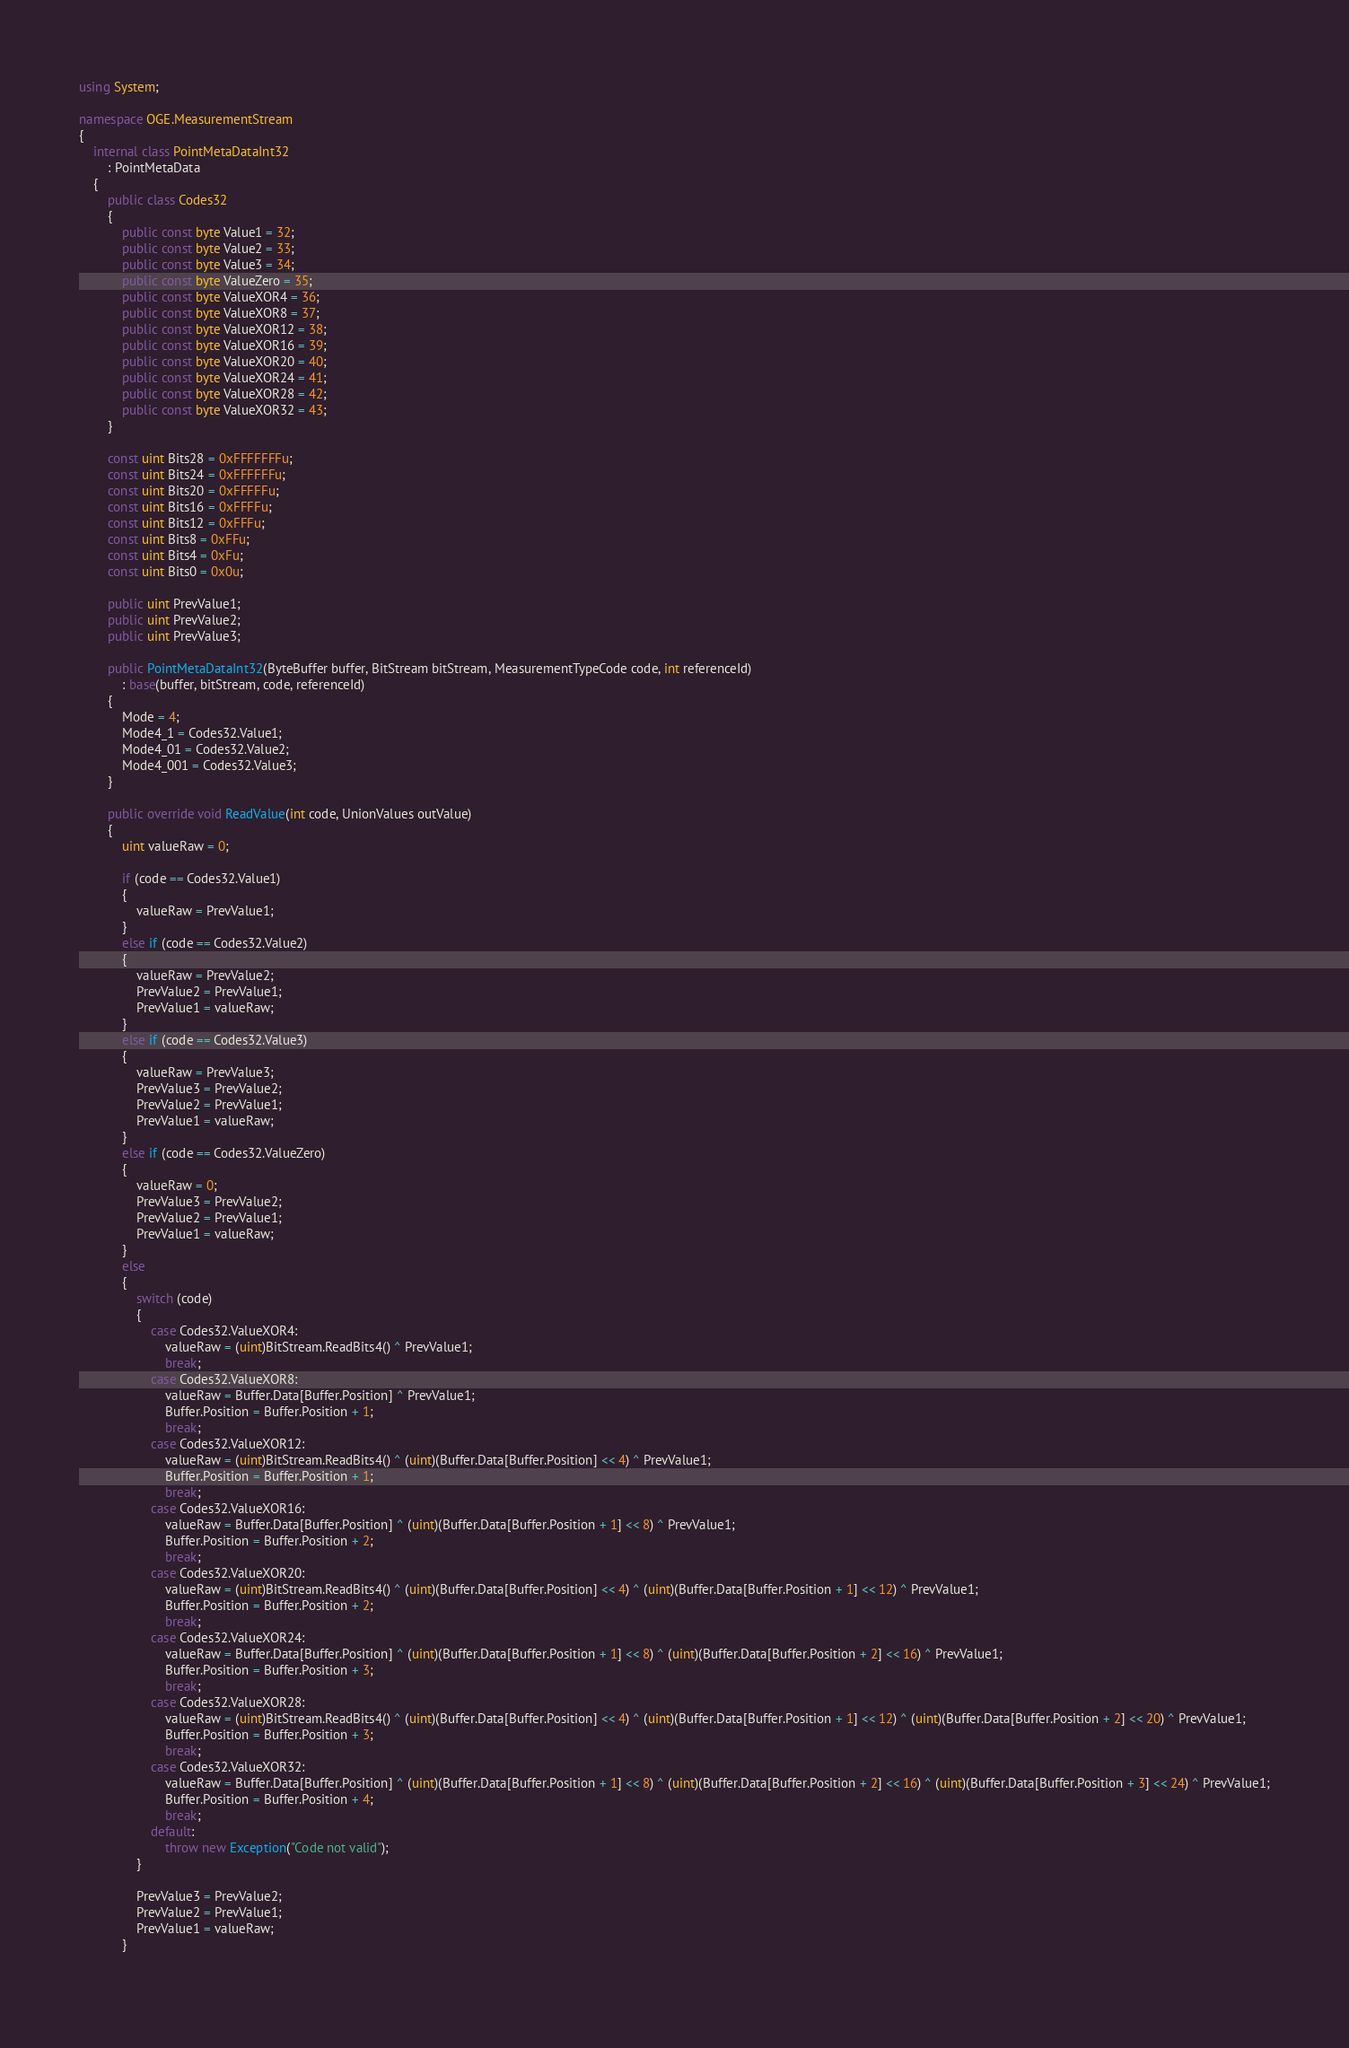<code> <loc_0><loc_0><loc_500><loc_500><_C#_>using System;

namespace OGE.MeasurementStream
{
    internal class PointMetaDataInt32
        : PointMetaData
    {
        public class Codes32
        {
            public const byte Value1 = 32;
            public const byte Value2 = 33;
            public const byte Value3 = 34;
            public const byte ValueZero = 35;
            public const byte ValueXOR4 = 36;
            public const byte ValueXOR8 = 37;
            public const byte ValueXOR12 = 38;
            public const byte ValueXOR16 = 39;
            public const byte ValueXOR20 = 40;
            public const byte ValueXOR24 = 41;
            public const byte ValueXOR28 = 42;
            public const byte ValueXOR32 = 43;
        }

        const uint Bits28 = 0xFFFFFFFu;
        const uint Bits24 = 0xFFFFFFu;
        const uint Bits20 = 0xFFFFFu;
        const uint Bits16 = 0xFFFFu;
        const uint Bits12 = 0xFFFu;
        const uint Bits8 = 0xFFu;
        const uint Bits4 = 0xFu;
        const uint Bits0 = 0x0u;

        public uint PrevValue1;
        public uint PrevValue2;
        public uint PrevValue3;

        public PointMetaDataInt32(ByteBuffer buffer, BitStream bitStream, MeasurementTypeCode code, int referenceId)
            : base(buffer, bitStream, code, referenceId)
        {
            Mode = 4;
            Mode4_1 = Codes32.Value1;
            Mode4_01 = Codes32.Value2;
            Mode4_001 = Codes32.Value3;
        }

        public override void ReadValue(int code, UnionValues outValue)
        {
            uint valueRaw = 0;

            if (code == Codes32.Value1)
            {
                valueRaw = PrevValue1;
            }
            else if (code == Codes32.Value2)
            {
                valueRaw = PrevValue2;
                PrevValue2 = PrevValue1;
                PrevValue1 = valueRaw;
            }
            else if (code == Codes32.Value3)
            {
                valueRaw = PrevValue3;
                PrevValue3 = PrevValue2;
                PrevValue2 = PrevValue1;
                PrevValue1 = valueRaw;
            }
            else if (code == Codes32.ValueZero)
            {
                valueRaw = 0;
                PrevValue3 = PrevValue2;
                PrevValue2 = PrevValue1;
                PrevValue1 = valueRaw;
            }
            else
            {
                switch (code)
                {
                    case Codes32.ValueXOR4:
                        valueRaw = (uint)BitStream.ReadBits4() ^ PrevValue1;
                        break;
                    case Codes32.ValueXOR8:
                        valueRaw = Buffer.Data[Buffer.Position] ^ PrevValue1;
                        Buffer.Position = Buffer.Position + 1;
                        break;
                    case Codes32.ValueXOR12:
                        valueRaw = (uint)BitStream.ReadBits4() ^ (uint)(Buffer.Data[Buffer.Position] << 4) ^ PrevValue1;
                        Buffer.Position = Buffer.Position + 1;
                        break;
                    case Codes32.ValueXOR16:
                        valueRaw = Buffer.Data[Buffer.Position] ^ (uint)(Buffer.Data[Buffer.Position + 1] << 8) ^ PrevValue1;
                        Buffer.Position = Buffer.Position + 2;
                        break;
                    case Codes32.ValueXOR20:
                        valueRaw = (uint)BitStream.ReadBits4() ^ (uint)(Buffer.Data[Buffer.Position] << 4) ^ (uint)(Buffer.Data[Buffer.Position + 1] << 12) ^ PrevValue1;
                        Buffer.Position = Buffer.Position + 2;
                        break;
                    case Codes32.ValueXOR24:
                        valueRaw = Buffer.Data[Buffer.Position] ^ (uint)(Buffer.Data[Buffer.Position + 1] << 8) ^ (uint)(Buffer.Data[Buffer.Position + 2] << 16) ^ PrevValue1;
                        Buffer.Position = Buffer.Position + 3;
                        break;
                    case Codes32.ValueXOR28:
                        valueRaw = (uint)BitStream.ReadBits4() ^ (uint)(Buffer.Data[Buffer.Position] << 4) ^ (uint)(Buffer.Data[Buffer.Position + 1] << 12) ^ (uint)(Buffer.Data[Buffer.Position + 2] << 20) ^ PrevValue1;
                        Buffer.Position = Buffer.Position + 3;
                        break;
                    case Codes32.ValueXOR32:
                        valueRaw = Buffer.Data[Buffer.Position] ^ (uint)(Buffer.Data[Buffer.Position + 1] << 8) ^ (uint)(Buffer.Data[Buffer.Position + 2] << 16) ^ (uint)(Buffer.Data[Buffer.Position + 3] << 24) ^ PrevValue1;
                        Buffer.Position = Buffer.Position + 4;
                        break;
                    default:
                        throw new Exception("Code not valid");
                }

                PrevValue3 = PrevValue2;
                PrevValue2 = PrevValue1;
                PrevValue1 = valueRaw;
            }
            </code> 